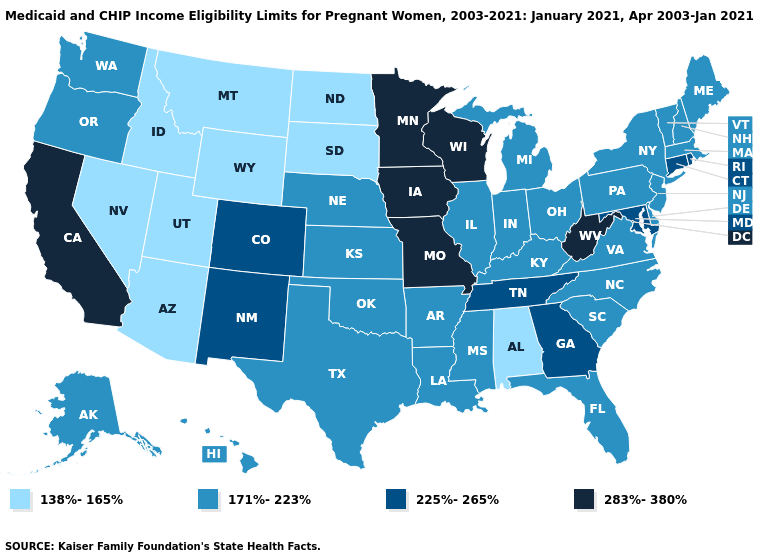What is the value of New York?
Keep it brief. 171%-223%. What is the value of Iowa?
Keep it brief. 283%-380%. Name the states that have a value in the range 283%-380%?
Concise answer only. California, Iowa, Minnesota, Missouri, West Virginia, Wisconsin. What is the lowest value in the Northeast?
Quick response, please. 171%-223%. What is the value of Oklahoma?
Keep it brief. 171%-223%. What is the value of New York?
Quick response, please. 171%-223%. What is the highest value in the MidWest ?
Be succinct. 283%-380%. Name the states that have a value in the range 283%-380%?
Give a very brief answer. California, Iowa, Minnesota, Missouri, West Virginia, Wisconsin. What is the value of Rhode Island?
Short answer required. 225%-265%. Which states have the lowest value in the USA?
Answer briefly. Alabama, Arizona, Idaho, Montana, Nevada, North Dakota, South Dakota, Utah, Wyoming. How many symbols are there in the legend?
Concise answer only. 4. Among the states that border Michigan , does Wisconsin have the highest value?
Give a very brief answer. Yes. Name the states that have a value in the range 171%-223%?
Be succinct. Alaska, Arkansas, Delaware, Florida, Hawaii, Illinois, Indiana, Kansas, Kentucky, Louisiana, Maine, Massachusetts, Michigan, Mississippi, Nebraska, New Hampshire, New Jersey, New York, North Carolina, Ohio, Oklahoma, Oregon, Pennsylvania, South Carolina, Texas, Vermont, Virginia, Washington. What is the value of Louisiana?
Short answer required. 171%-223%. Among the states that border Alabama , does Georgia have the lowest value?
Give a very brief answer. No. 